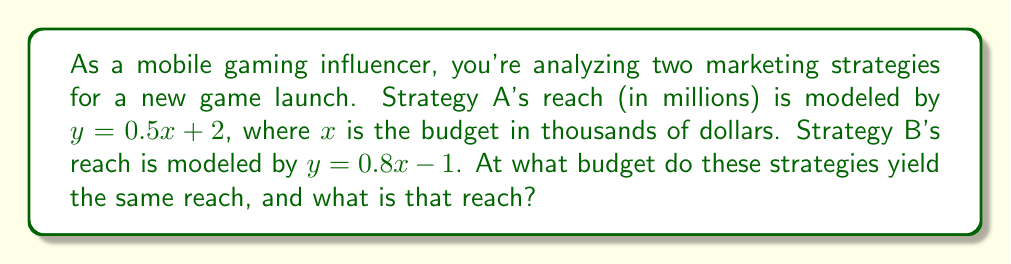What is the answer to this math problem? To find the intersection point of these two linear equations, we need to solve them simultaneously:

1) Set the equations equal to each other:
   $$0.5x + 2 = 0.8x - 1$$

2) Subtract $0.5x$ from both sides:
   $$2 = 0.3x - 1$$

3) Add 1 to both sides:
   $$3 = 0.3x$$

4) Divide both sides by 0.3:
   $$10 = x$$

5) Now that we know $x = 10$, we can substitute this into either equation to find $y$. Let's use Strategy A's equation:
   $$y = 0.5(10) + 2 = 5 + 2 = 7$$

6) Therefore, the intersection point is $(10, 7)$, meaning at a budget of $10,000, both strategies will reach 7 million people.
Answer: $(10, 7)$ 